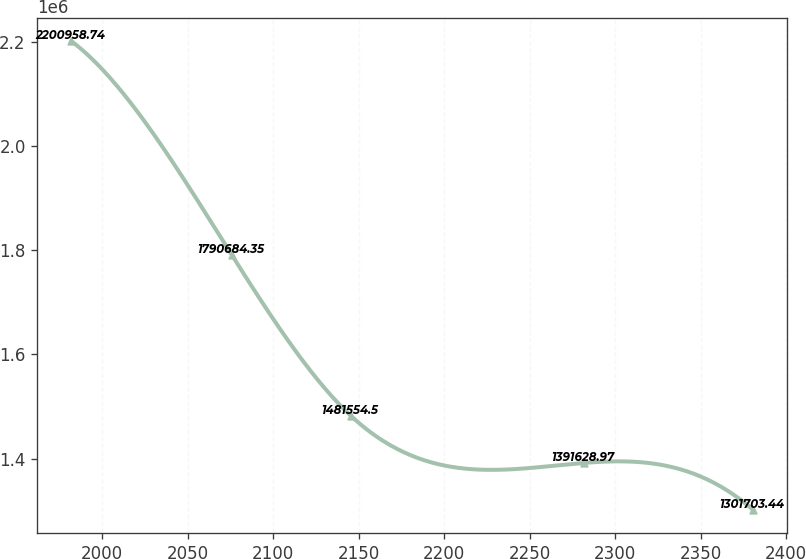<chart> <loc_0><loc_0><loc_500><loc_500><line_chart><ecel><fcel>Unnamed: 1<nl><fcel>1981.96<fcel>2.20096e+06<nl><fcel>2075.77<fcel>1.79068e+06<nl><fcel>2145.57<fcel>1.48155e+06<nl><fcel>2281.6<fcel>1.39163e+06<nl><fcel>2380.61<fcel>1.3017e+06<nl></chart> 